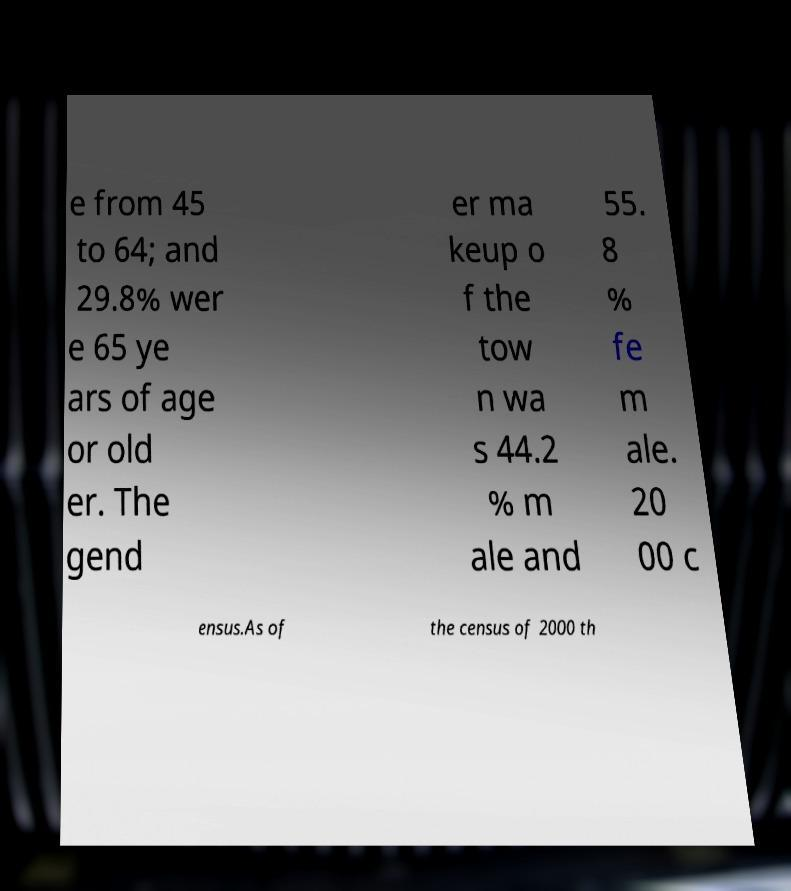Please identify and transcribe the text found in this image. e from 45 to 64; and 29.8% wer e 65 ye ars of age or old er. The gend er ma keup o f the tow n wa s 44.2 % m ale and 55. 8 % fe m ale. 20 00 c ensus.As of the census of 2000 th 